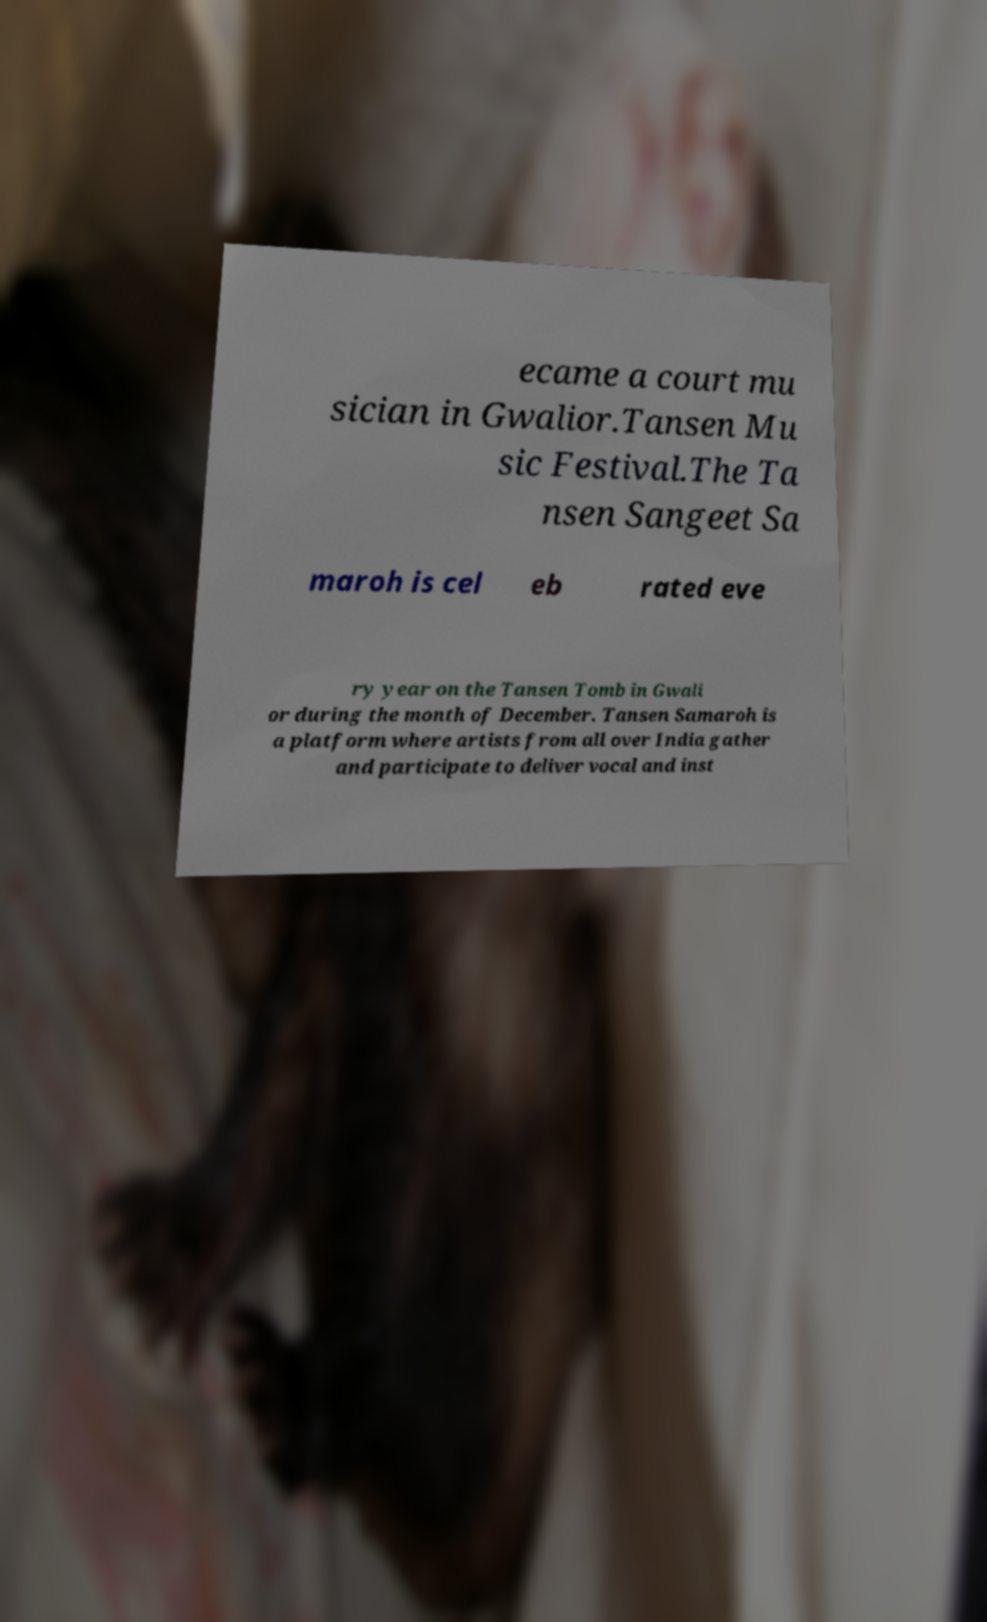What messages or text are displayed in this image? I need them in a readable, typed format. ecame a court mu sician in Gwalior.Tansen Mu sic Festival.The Ta nsen Sangeet Sa maroh is cel eb rated eve ry year on the Tansen Tomb in Gwali or during the month of December. Tansen Samaroh is a platform where artists from all over India gather and participate to deliver vocal and inst 